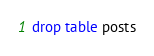<code> <loc_0><loc_0><loc_500><loc_500><_SQL_>drop table posts
</code> 